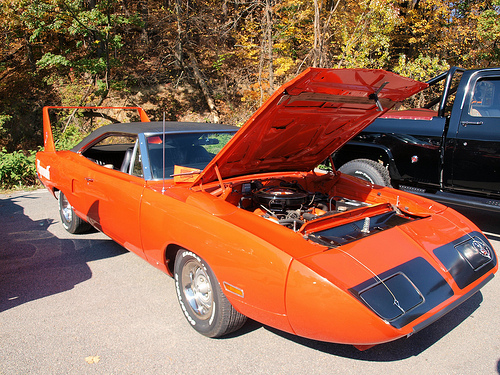<image>
Can you confirm if the black car is to the right of the orange car? Yes. From this viewpoint, the black car is positioned to the right side relative to the orange car. 